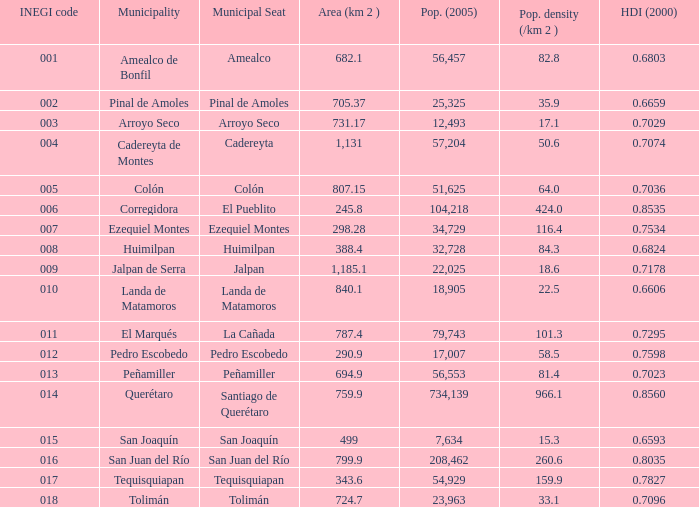Which Area (km 2 )has a Population (2005) of 57,204, and a Human Development Index (2000) smaller than 0.7074? 0.0. 